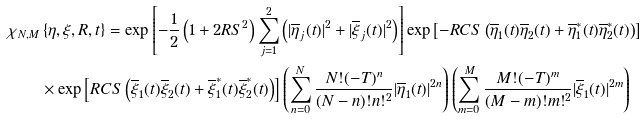<formula> <loc_0><loc_0><loc_500><loc_500>\chi _ { N , M } & \left \{ \eta , \xi , R , t \right \} = \exp \left [ - \frac { 1 } { 2 } \left ( 1 + 2 R S ^ { 2 } \right ) \sum _ { j = 1 } ^ { 2 } \left ( | \overline { \eta } _ { j } ( t ) | ^ { 2 } + | \overline { \xi } _ { j } ( t ) | ^ { 2 } \right ) \right ] \exp \left [ - R C S \left ( \overline { \eta } _ { 1 } ( t ) \overline { \eta } _ { 2 } ( t ) + \overline { \eta } _ { 1 } ^ { \ast } ( t ) \overline { \eta } _ { 2 } ^ { \ast } ( t ) \right ) \right ] \\ & \times \exp \left [ R C S \left ( \overline { \xi } _ { 1 } ( t ) \overline { \xi } _ { 2 } ( t ) + \overline { \xi } _ { 1 } ^ { \ast } ( t ) \overline { \xi } _ { 2 } ^ { \ast } ( t ) \right ) \right ] \left ( \sum _ { n = 0 } ^ { N } \frac { N ! ( - T ) ^ { n } } { ( N - n ) ! n ! ^ { 2 } } | \overline { \eta } _ { 1 } ( t ) | ^ { 2 n } \right ) \left ( \sum _ { m = 0 } ^ { M } \frac { M ! ( - T ) ^ { m } } { ( M - m ) ! m ! ^ { 2 } } | \overline { \xi } _ { 1 } ( t ) | ^ { 2 m } \right )</formula> 